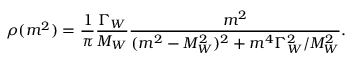<formula> <loc_0><loc_0><loc_500><loc_500>\rho ( m ^ { 2 } ) = { \frac { 1 } { \pi } } { \frac { \Gamma _ { W } } { M _ { W } } } { \frac { m ^ { 2 } } { ( m ^ { 2 } - M _ { W } ^ { 2 } ) ^ { 2 } + m ^ { 4 } \Gamma _ { W } ^ { 2 } / M _ { W } ^ { 2 } } } .</formula> 